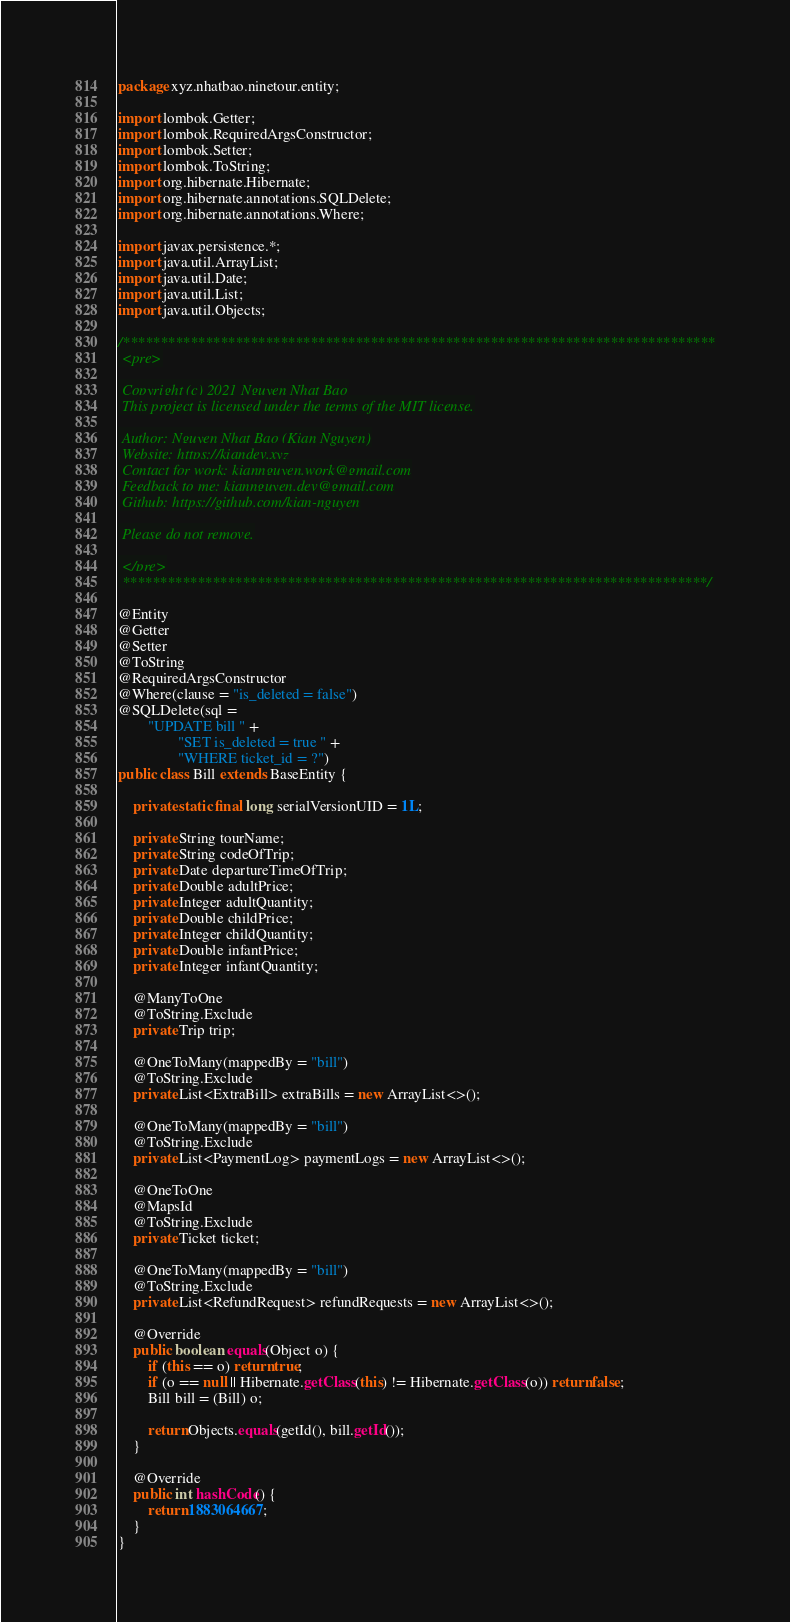Convert code to text. <code><loc_0><loc_0><loc_500><loc_500><_Java_>package xyz.nhatbao.ninetour.entity;

import lombok.Getter;
import lombok.RequiredArgsConstructor;
import lombok.Setter;
import lombok.ToString;
import org.hibernate.Hibernate;
import org.hibernate.annotations.SQLDelete;
import org.hibernate.annotations.Where;

import javax.persistence.*;
import java.util.ArrayList;
import java.util.Date;
import java.util.List;
import java.util.Objects;

/*******************************************************************************
 <pre>

 Copyright (c) 2021 Nguyen Nhat Bao
 This project is licensed under the terms of the MIT license.

 Author: Nguyen Nhat Bao (Kian Nguyen)
 Website: https://kiandev.xyz
 Contact for work: kiannguyen.work@gmail.com
 Feedback to me: kiannguyen.dev@gmail.com
 Github: https://github.com/kian-nguyen

 Please do not remove.

 </pre>
 ******************************************************************************/

@Entity
@Getter
@Setter
@ToString
@RequiredArgsConstructor
@Where(clause = "is_deleted = false")
@SQLDelete(sql =
        "UPDATE bill " +
                "SET is_deleted = true " +
                "WHERE ticket_id = ?")
public class Bill extends BaseEntity {

    private static final long serialVersionUID = 1L;

    private String tourName;
    private String codeOfTrip;
    private Date departureTimeOfTrip;
    private Double adultPrice;
    private Integer adultQuantity;
    private Double childPrice;
    private Integer childQuantity;
    private Double infantPrice;
    private Integer infantQuantity;

    @ManyToOne
    @ToString.Exclude
    private Trip trip;

    @OneToMany(mappedBy = "bill")
    @ToString.Exclude
    private List<ExtraBill> extraBills = new ArrayList<>();

    @OneToMany(mappedBy = "bill")
    @ToString.Exclude
    private List<PaymentLog> paymentLogs = new ArrayList<>();

    @OneToOne
    @MapsId
    @ToString.Exclude
    private Ticket ticket;

    @OneToMany(mappedBy = "bill")
    @ToString.Exclude
    private List<RefundRequest> refundRequests = new ArrayList<>();

    @Override
    public boolean equals(Object o) {
        if (this == o) return true;
        if (o == null || Hibernate.getClass(this) != Hibernate.getClass(o)) return false;
        Bill bill = (Bill) o;

        return Objects.equals(getId(), bill.getId());
    }

    @Override
    public int hashCode() {
        return 1883064667;
    }
}
</code> 